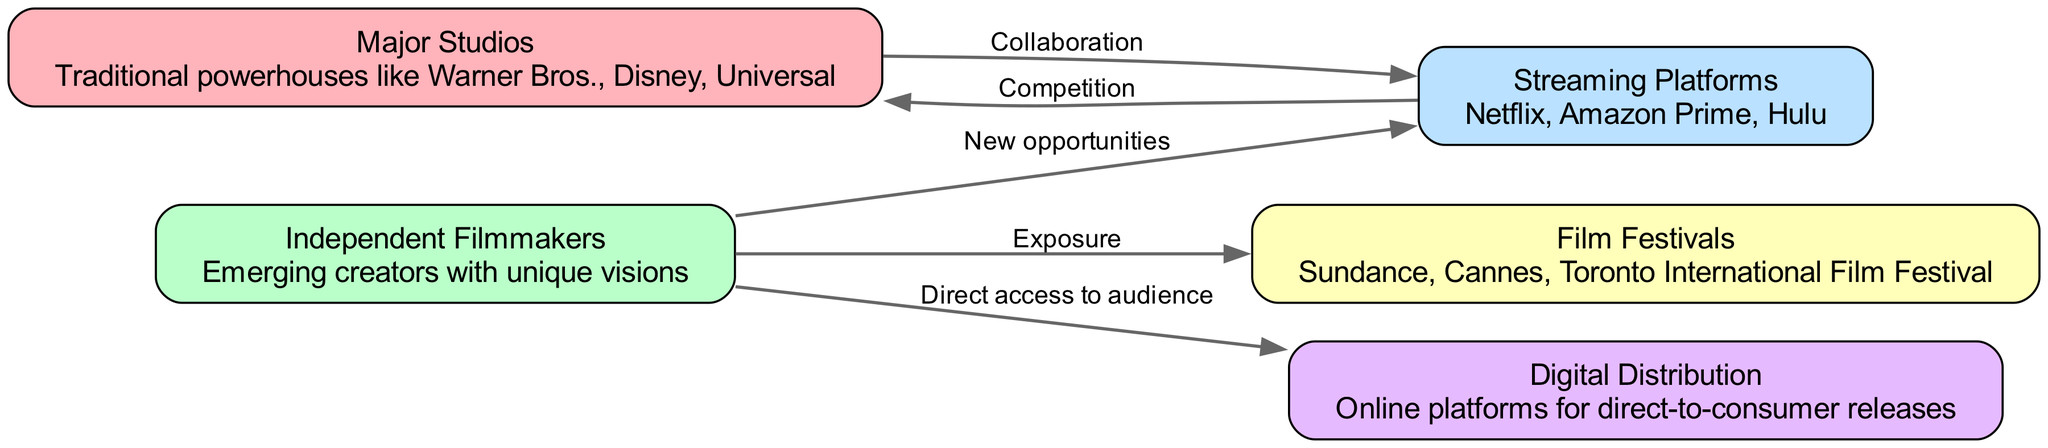What are the major studios listed in the diagram? The nodes represent different entities in the film industry, and "Major Studios" is one of them, with the description showing traditional powerhouses.
Answer: Warner Bros., Disney, Universal How many nodes are represented in the diagram? By counting the entities listed in the 'nodes' section, there are a total of five distinct groups identified: Major Studios, Independent Filmmakers, Streaming Platforms, Film Festivals, and Digital Distribution.
Answer: 5 What relationship exists between major studios and streaming platforms? The edge from "Major Studios" to "Streaming Platforms" is labeled as "Collaboration," indicating a cooperative relationship between the two entities.
Answer: Collaboration Which entity has direct access to audiences according to the diagram? The edge from "Independent Filmmakers" to "Digital Distribution" indicates that independent filmmakers utilize platforms for direct access to audiences.
Answer: Independent Filmmakers What is the primary competitive force against major studios? The diagram shows an edge labeled "Competition" from "Streaming Platforms" to "Major Studios," indicating streaming platforms pose a competitive challenge to traditional studios.
Answer: Streaming Platforms How many edges are there connecting independent filmmakers to other entities? Counting the edges connected to "Independent Filmmakers," there are three outgoing edges leading to Streaming Platforms, Film Festivals, and Digital Distribution.
Answer: 3 What opportunity is primarily available for independent filmmakers through streaming platforms? The diagram indicates that independent filmmakers find "New opportunities" through their relationship with streaming platforms, represented by an edge.
Answer: New opportunities Which film festivals are mentioned in the diagram? The description under the "Film Festivals" node references prominent festivals without listing them directly in the diagram, but culturally signifies their importance to independent filmmakers.
Answer: Sundance, Cannes, Toronto International Film Festival What is the significance of digital distribution for independent filmmakers? The edge from "Independent Filmmakers" to "Digital Distribution" signifies "Direct access to audience," highlighting its role in enabling filmmakers to reach viewers without intermediaries.
Answer: Direct access to audience 